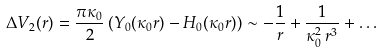<formula> <loc_0><loc_0><loc_500><loc_500>\Delta V _ { 2 } ( r ) = \frac { \pi \kappa _ { 0 } } { 2 } \left ( Y _ { 0 } ( \kappa _ { 0 } r ) - H _ { 0 } ( \kappa _ { 0 } r ) \right ) \sim - \frac { 1 } { r } + \frac { 1 } { \kappa _ { 0 } ^ { 2 } \, r ^ { 3 } } + \dots</formula> 